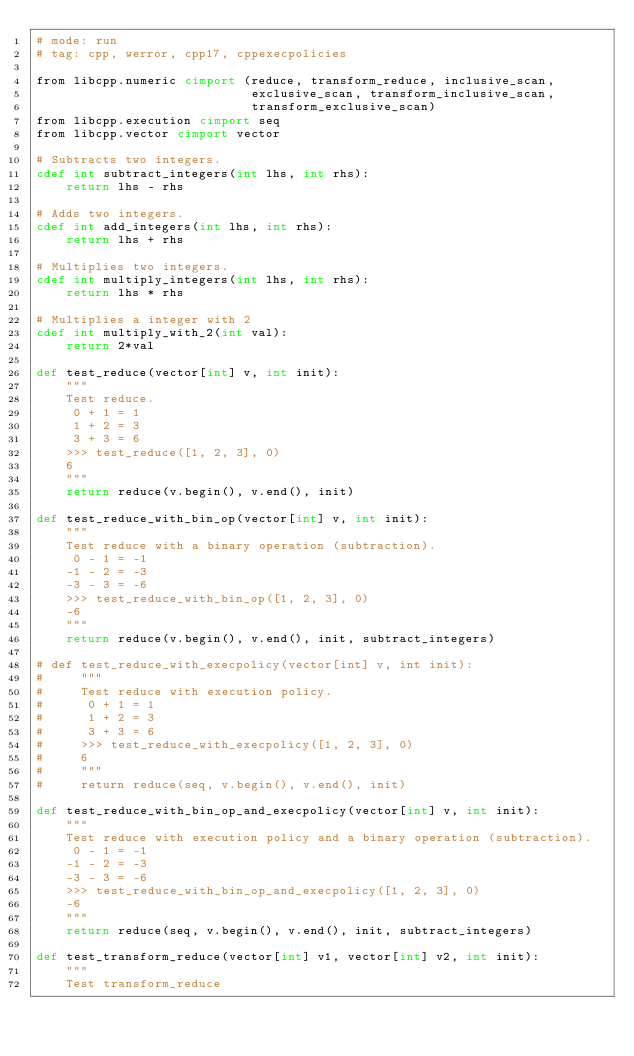Convert code to text. <code><loc_0><loc_0><loc_500><loc_500><_Cython_># mode: run
# tag: cpp, werror, cpp17, cppexecpolicies

from libcpp.numeric cimport (reduce, transform_reduce, inclusive_scan, 
                             exclusive_scan, transform_inclusive_scan, 
                             transform_exclusive_scan)
from libcpp.execution cimport seq
from libcpp.vector cimport vector

# Subtracts two integers.
cdef int subtract_integers(int lhs, int rhs):
    return lhs - rhs

# Adds two integers.
cdef int add_integers(int lhs, int rhs):
    return lhs + rhs

# Multiplies two integers.
cdef int multiply_integers(int lhs, int rhs):
    return lhs * rhs

# Multiplies a integer with 2
cdef int multiply_with_2(int val):
    return 2*val

def test_reduce(vector[int] v, int init):
    """
    Test reduce.
     0 + 1 = 1
     1 + 2 = 3
     3 + 3 = 6
    >>> test_reduce([1, 2, 3], 0)
    6
    """
    return reduce(v.begin(), v.end(), init)

def test_reduce_with_bin_op(vector[int] v, int init):
    """
    Test reduce with a binary operation (subtraction). 
     0 - 1 = -1
    -1 - 2 = -3
    -3 - 3 = -6
    >>> test_reduce_with_bin_op([1, 2, 3], 0)
    -6
    """
    return reduce(v.begin(), v.end(), init, subtract_integers)

# def test_reduce_with_execpolicy(vector[int] v, int init):
#     """
#     Test reduce with execution policy. 
#      0 + 1 = 1
#      1 + 2 = 3
#      3 + 3 = 6
#     >>> test_reduce_with_execpolicy([1, 2, 3], 0)
#     6
#     """
#     return reduce(seq, v.begin(), v.end(), init)

def test_reduce_with_bin_op_and_execpolicy(vector[int] v, int init):
    """
    Test reduce with execution policy and a binary operation (subtraction). 
     0 - 1 = -1
    -1 - 2 = -3
    -3 - 3 = -6
    >>> test_reduce_with_bin_op_and_execpolicy([1, 2, 3], 0)
    -6
    """
    return reduce(seq, v.begin(), v.end(), init, subtract_integers)

def test_transform_reduce(vector[int] v1, vector[int] v2, int init):
    """
    Test transform_reduce</code> 